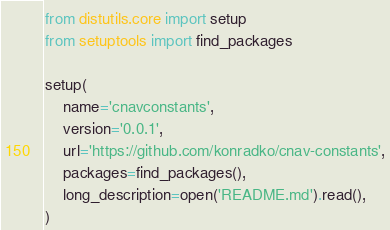Convert code to text. <code><loc_0><loc_0><loc_500><loc_500><_Python_>from distutils.core import setup
from setuptools import find_packages

setup(
    name='cnavconstants',
    version='0.0.1',
    url='https://github.com/konradko/cnav-constants',
    packages=find_packages(),
    long_description=open('README.md').read(),
)
</code> 